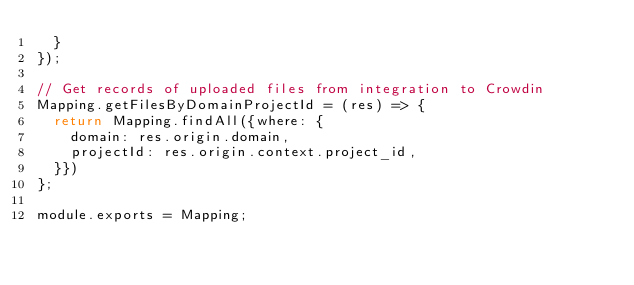<code> <loc_0><loc_0><loc_500><loc_500><_JavaScript_>  }
});

// Get records of uploaded files from integration to Crowdin
Mapping.getFilesByDomainProjectId = (res) => {
  return Mapping.findAll({where: {
    domain: res.origin.domain,
    projectId: res.origin.context.project_id,
  }})
};

module.exports = Mapping;</code> 